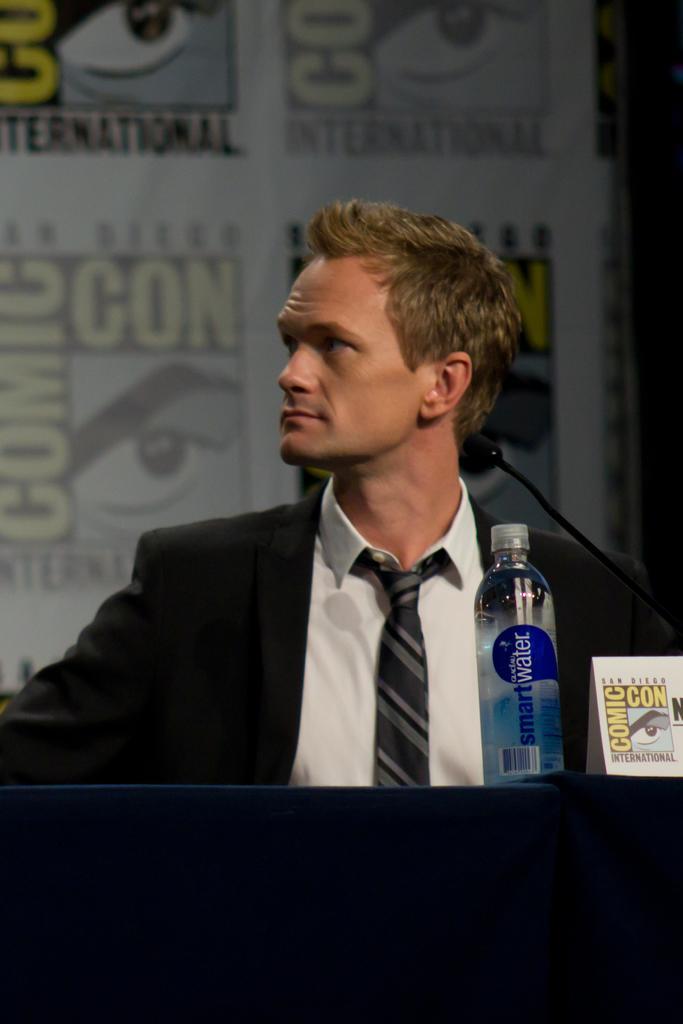Can you describe this image briefly? In the center we can see one person sitting on the chair. In front there is a table,on table we can see cloth,water bottle and paper. In the background there is a wall. 